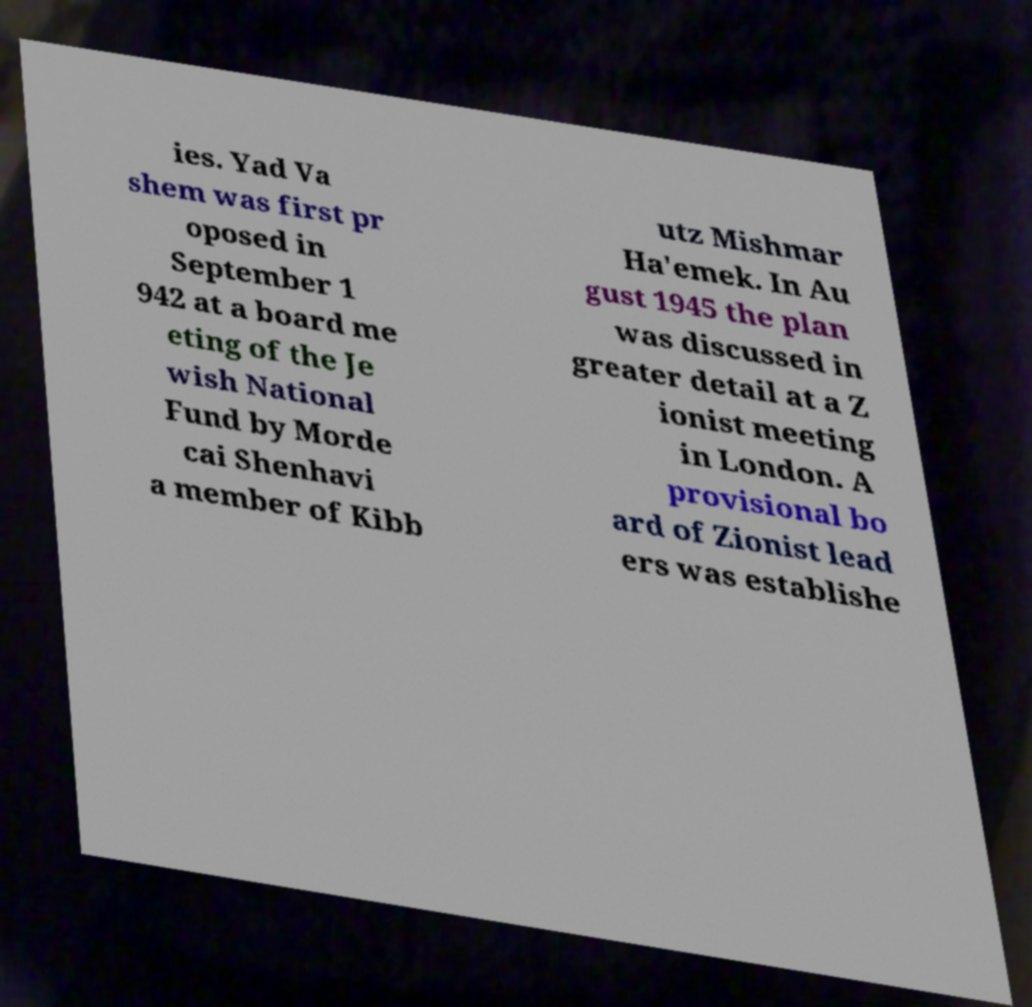Can you read and provide the text displayed in the image?This photo seems to have some interesting text. Can you extract and type it out for me? ies. Yad Va shem was first pr oposed in September 1 942 at a board me eting of the Je wish National Fund by Morde cai Shenhavi a member of Kibb utz Mishmar Ha'emek. In Au gust 1945 the plan was discussed in greater detail at a Z ionist meeting in London. A provisional bo ard of Zionist lead ers was establishe 